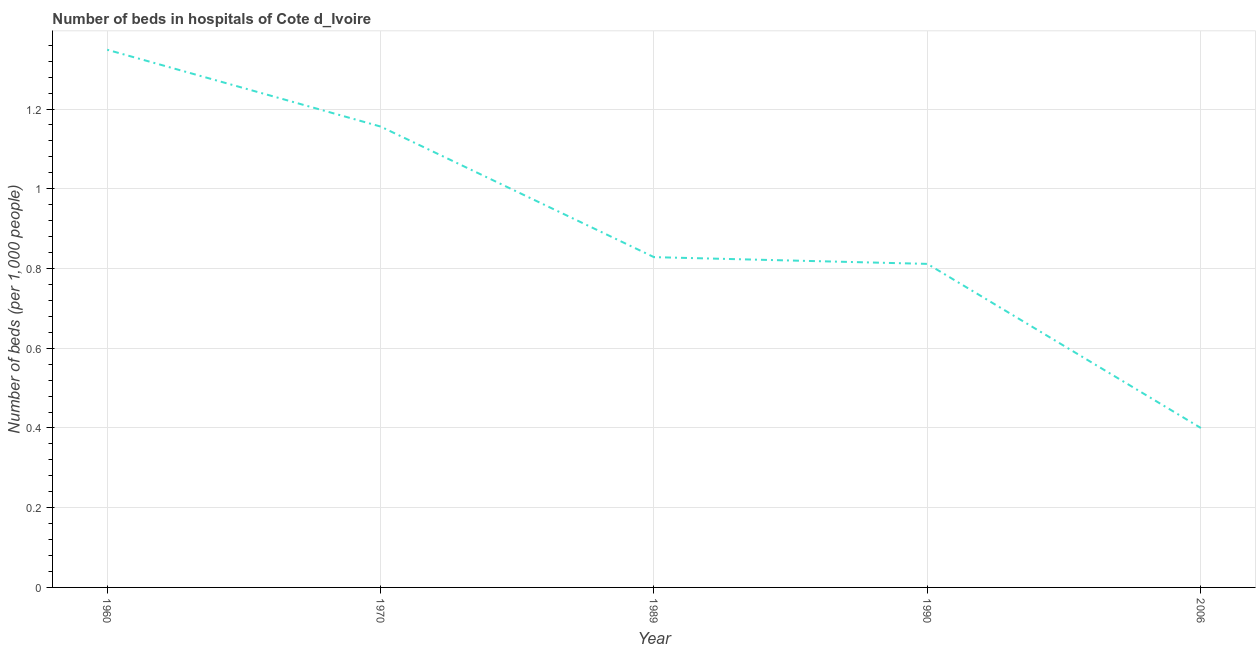What is the number of hospital beds in 1990?
Keep it short and to the point. 0.81. Across all years, what is the maximum number of hospital beds?
Offer a very short reply. 1.35. What is the sum of the number of hospital beds?
Provide a short and direct response. 4.54. What is the difference between the number of hospital beds in 1970 and 1989?
Offer a very short reply. 0.33. What is the average number of hospital beds per year?
Keep it short and to the point. 0.91. What is the median number of hospital beds?
Your answer should be very brief. 0.83. Do a majority of the years between 2006 and 1989 (inclusive) have number of hospital beds greater than 0.44 %?
Your answer should be compact. No. What is the ratio of the number of hospital beds in 1989 to that in 2006?
Ensure brevity in your answer.  2.07. What is the difference between the highest and the second highest number of hospital beds?
Provide a succinct answer. 0.19. Is the sum of the number of hospital beds in 1960 and 1990 greater than the maximum number of hospital beds across all years?
Give a very brief answer. Yes. What is the difference between the highest and the lowest number of hospital beds?
Ensure brevity in your answer.  0.95. In how many years, is the number of hospital beds greater than the average number of hospital beds taken over all years?
Your answer should be very brief. 2. Does the number of hospital beds monotonically increase over the years?
Your answer should be very brief. No. What is the difference between two consecutive major ticks on the Y-axis?
Your response must be concise. 0.2. Does the graph contain any zero values?
Offer a very short reply. No. Does the graph contain grids?
Make the answer very short. Yes. What is the title of the graph?
Ensure brevity in your answer.  Number of beds in hospitals of Cote d_Ivoire. What is the label or title of the Y-axis?
Offer a terse response. Number of beds (per 1,0 people). What is the Number of beds (per 1,000 people) of 1960?
Give a very brief answer. 1.35. What is the Number of beds (per 1,000 people) of 1970?
Keep it short and to the point. 1.16. What is the Number of beds (per 1,000 people) in 1989?
Make the answer very short. 0.83. What is the Number of beds (per 1,000 people) of 1990?
Offer a very short reply. 0.81. What is the Number of beds (per 1,000 people) of 2006?
Your response must be concise. 0.4. What is the difference between the Number of beds (per 1,000 people) in 1960 and 1970?
Make the answer very short. 0.19. What is the difference between the Number of beds (per 1,000 people) in 1960 and 1989?
Give a very brief answer. 0.52. What is the difference between the Number of beds (per 1,000 people) in 1960 and 1990?
Keep it short and to the point. 0.54. What is the difference between the Number of beds (per 1,000 people) in 1960 and 2006?
Your response must be concise. 0.95. What is the difference between the Number of beds (per 1,000 people) in 1970 and 1989?
Keep it short and to the point. 0.33. What is the difference between the Number of beds (per 1,000 people) in 1970 and 1990?
Your answer should be compact. 0.34. What is the difference between the Number of beds (per 1,000 people) in 1970 and 2006?
Your response must be concise. 0.76. What is the difference between the Number of beds (per 1,000 people) in 1989 and 1990?
Your answer should be very brief. 0.02. What is the difference between the Number of beds (per 1,000 people) in 1989 and 2006?
Your response must be concise. 0.43. What is the difference between the Number of beds (per 1,000 people) in 1990 and 2006?
Offer a very short reply. 0.41. What is the ratio of the Number of beds (per 1,000 people) in 1960 to that in 1970?
Make the answer very short. 1.17. What is the ratio of the Number of beds (per 1,000 people) in 1960 to that in 1989?
Your response must be concise. 1.63. What is the ratio of the Number of beds (per 1,000 people) in 1960 to that in 1990?
Keep it short and to the point. 1.66. What is the ratio of the Number of beds (per 1,000 people) in 1960 to that in 2006?
Provide a short and direct response. 3.37. What is the ratio of the Number of beds (per 1,000 people) in 1970 to that in 1989?
Provide a succinct answer. 1.4. What is the ratio of the Number of beds (per 1,000 people) in 1970 to that in 1990?
Offer a terse response. 1.42. What is the ratio of the Number of beds (per 1,000 people) in 1970 to that in 2006?
Give a very brief answer. 2.89. What is the ratio of the Number of beds (per 1,000 people) in 1989 to that in 1990?
Offer a terse response. 1.02. What is the ratio of the Number of beds (per 1,000 people) in 1989 to that in 2006?
Provide a short and direct response. 2.07. What is the ratio of the Number of beds (per 1,000 people) in 1990 to that in 2006?
Provide a short and direct response. 2.03. 